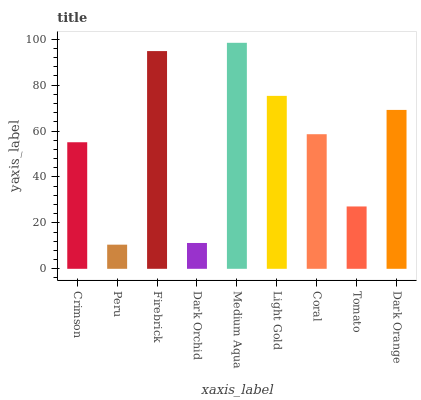Is Peru the minimum?
Answer yes or no. Yes. Is Medium Aqua the maximum?
Answer yes or no. Yes. Is Firebrick the minimum?
Answer yes or no. No. Is Firebrick the maximum?
Answer yes or no. No. Is Firebrick greater than Peru?
Answer yes or no. Yes. Is Peru less than Firebrick?
Answer yes or no. Yes. Is Peru greater than Firebrick?
Answer yes or no. No. Is Firebrick less than Peru?
Answer yes or no. No. Is Coral the high median?
Answer yes or no. Yes. Is Coral the low median?
Answer yes or no. Yes. Is Peru the high median?
Answer yes or no. No. Is Crimson the low median?
Answer yes or no. No. 